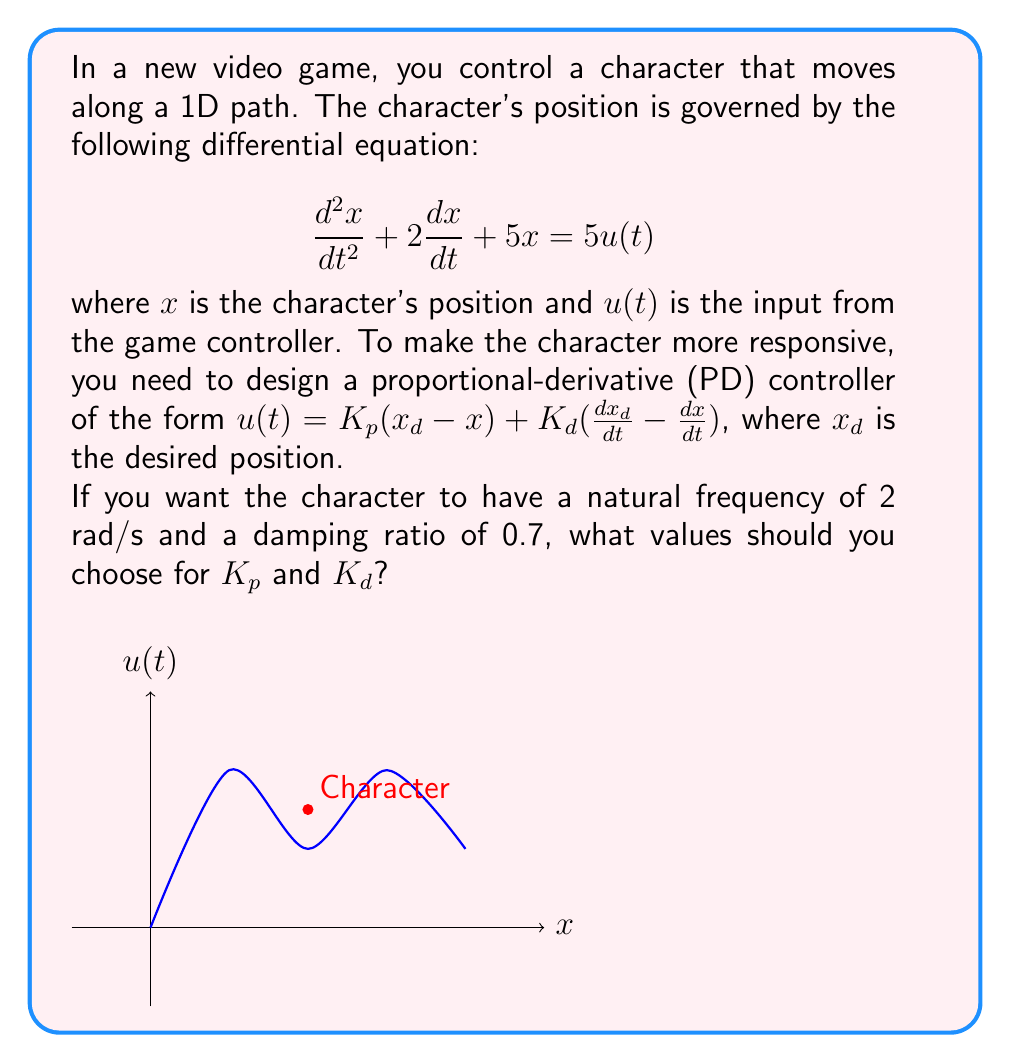Can you solve this math problem? Let's approach this step-by-step:

1) The closed-loop transfer function of the system with PD control is:

   $$\frac{X(s)}{X_d(s)} = \frac{5K_ps + 5K_d}{s^2 + (2+5K_d)s + (5+5K_p)}$$

2) The standard form of a second-order transfer function is:

   $$\frac{\omega_n^2}{s^2 + 2\zeta\omega_n s + \omega_n^2}$$

   where $\omega_n$ is the natural frequency and $\zeta$ is the damping ratio.

3) Comparing our transfer function to the standard form, we can see that:

   $$2+5K_d = 2\zeta\omega_n$$
   $$5+5K_p = \omega_n^2$$

4) We're given that $\omega_n = 2$ rad/s and $\zeta = 0.7$. Let's substitute these values:

   $$2+5K_d = 2(0.7)(2) = 2.8$$
   $$5+5K_p = 2^2 = 4$$

5) Solving these equations:

   $$5K_d = 0.8 \Rightarrow K_d = 0.16$$
   $$5K_p = -1 \Rightarrow K_p = -0.2$$

Therefore, the values for $K_p$ and $K_d$ should be -0.2 and 0.16 respectively.
Answer: $K_p = -0.2$, $K_d = 0.16$ 